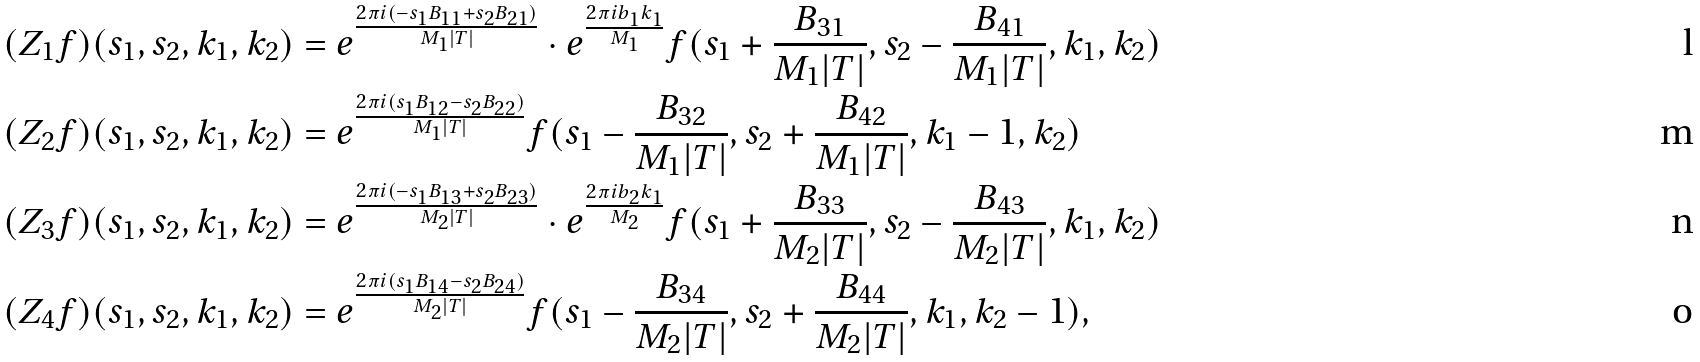Convert formula to latex. <formula><loc_0><loc_0><loc_500><loc_500>( Z _ { 1 } f ) ( s _ { 1 } , s _ { 2 } , k _ { 1 } , k _ { 2 } ) & = e ^ { \frac { 2 \pi i ( - s _ { 1 } B _ { 1 1 } + s _ { 2 } B _ { 2 1 } ) } { M _ { 1 } | T | } } \cdot e ^ { \frac { 2 \pi i b _ { 1 } k _ { 1 } } { M _ { 1 } } } f ( s _ { 1 } + \frac { B _ { 3 1 } } { M _ { 1 } | T | } , s _ { 2 } - \frac { B _ { 4 1 } } { M _ { 1 } | T | } , k _ { 1 } , k _ { 2 } ) \\ ( Z _ { 2 } f ) ( s _ { 1 } , s _ { 2 } , k _ { 1 } , k _ { 2 } ) & = e ^ { \frac { 2 \pi i ( s _ { 1 } B _ { 1 2 } - s _ { 2 } B _ { 2 2 } ) } { M _ { 1 } | T | } } f ( s _ { 1 } - \frac { B _ { 3 2 } } { M _ { 1 } | T | } , s _ { 2 } + \frac { B _ { 4 2 } } { M _ { 1 } | T | } , k _ { 1 } - 1 , k _ { 2 } ) \\ ( Z _ { 3 } f ) ( s _ { 1 } , s _ { 2 } , k _ { 1 } , k _ { 2 } ) & = e ^ { \frac { 2 \pi i ( - s _ { 1 } B _ { 1 3 } + s _ { 2 } B _ { 2 3 } ) } { M _ { 2 } | T | } } \cdot e ^ { \frac { 2 \pi i b _ { 2 } k _ { 1 } } { M _ { 2 } } } f ( s _ { 1 } + \frac { B _ { 3 3 } } { M _ { 2 } | T | } , s _ { 2 } - \frac { B _ { 4 3 } } { M _ { 2 } | T | } , k _ { 1 } , k _ { 2 } ) \\ ( Z _ { 4 } f ) ( s _ { 1 } , s _ { 2 } , k _ { 1 } , k _ { 2 } ) & = e ^ { \frac { 2 \pi i ( s _ { 1 } B _ { 1 4 } - s _ { 2 } B _ { 2 4 } ) } { M _ { 2 } | T | } } f ( s _ { 1 } - \frac { B _ { 3 4 } } { M _ { 2 } | T | } , s _ { 2 } + \frac { B _ { 4 4 } } { M _ { 2 } | T | } , k _ { 1 } , k _ { 2 } - 1 ) ,</formula> 